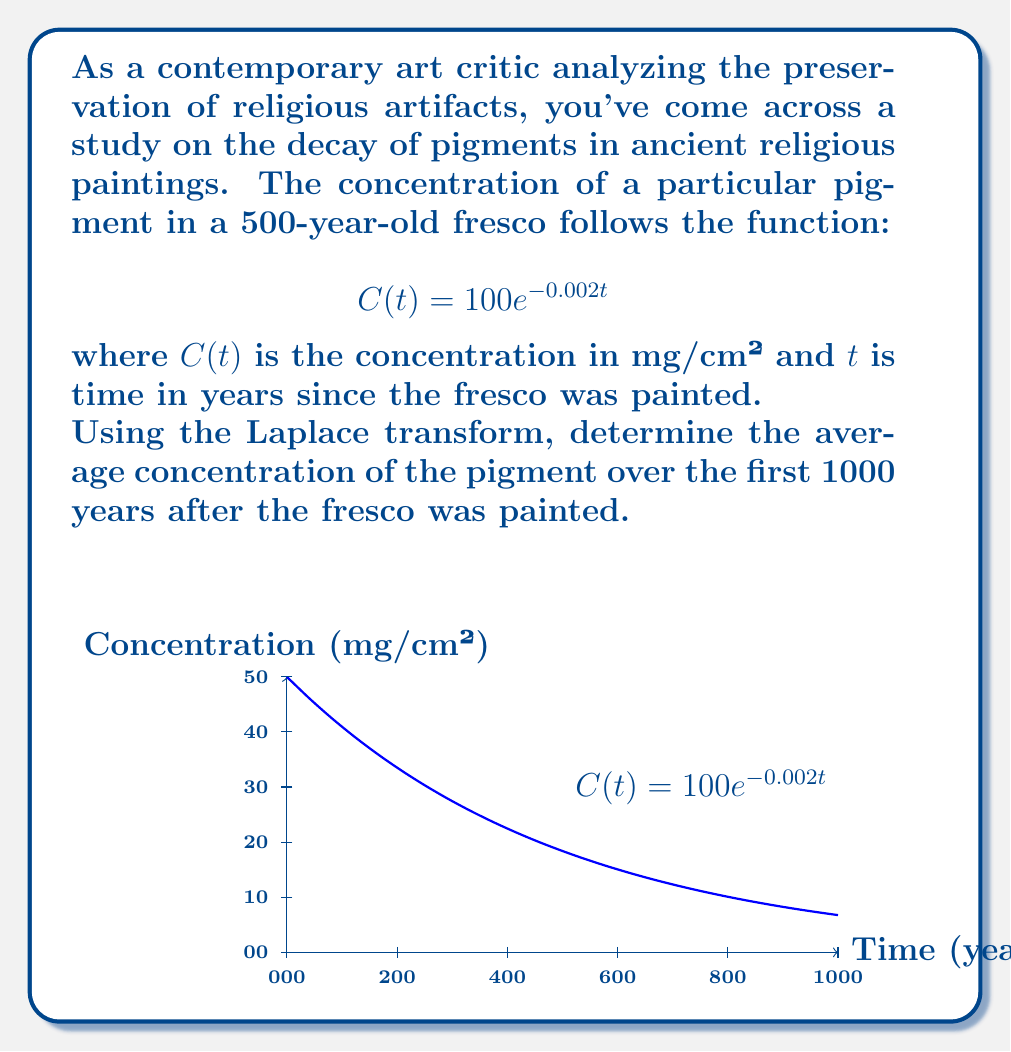Help me with this question. To solve this problem, we'll use the following steps:

1) The average concentration over time T is given by:

   $$\bar{C} = \frac{1}{T}\int_0^T C(t)dt$$

2) We need to find $\bar{C}$ for T = 1000 years. Let's use the Laplace transform to solve this integral.

3) The Laplace transform of $e^{-at}$ is $\frac{1}{s+a}$. Therefore:

   $$\mathcal{L}\{C(t)\} = 100 \cdot \mathcal{L}\{e^{-0.002t}\} = \frac{100}{s+0.002}$$

4) To find the integral of $C(t)$ from 0 to T, we multiply by $\frac{1}{s}$ and then take the inverse Laplace transform:

   $$\mathcal{L}^{-1}\{\frac{1}{s} \cdot \frac{100}{s+0.002}\} = 100 \cdot \frac{1-e^{-0.002T}}{0.002}$$

5) Now we can calculate the average concentration:

   $$\bar{C} = \frac{1}{1000} \cdot 100 \cdot \frac{1-e^{-0.002 \cdot 1000}}{0.002}$$

6) Simplifying:

   $$\bar{C} = \frac{100}{2} \cdot \frac{1-e^{-2}}{1000} \approx 0.0432 \text{ mg/cm²}$$

This result shows how the Laplace transform can be used to analyze the long-term behavior of decaying pigments in religious artifacts, aiding in their preservation as cultural heritage.
Answer: $0.0432 \text{ mg/cm²}$ 